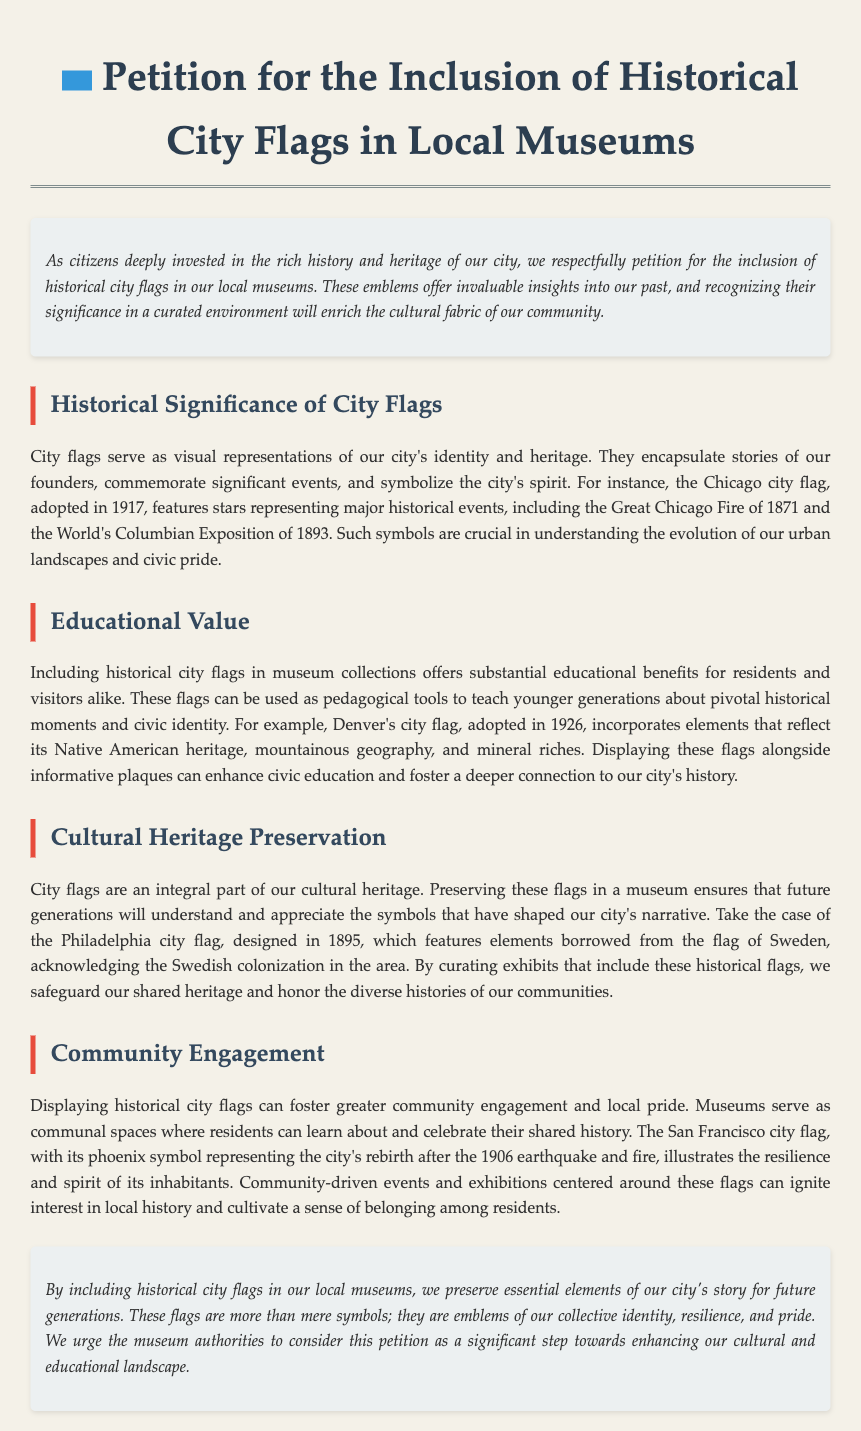what is the title of the petition? The title is clearly stated at the top of the document in a prominent header format.
Answer: Petition for the Inclusion of Historical City Flags in Local Museums when was the Chicago city flag adopted? The document specifies the adoption year of the Chicago city flag as part of its historical significance section.
Answer: 1917 what does the Denver city flag represent? The document describes elements of the Denver city flag that reflect certain aspects of the city's identity.
Answer: Native American heritage which city flag features a phoenix? The document mentions a specific city flag and its symbolism related to a significant historical event.
Answer: San Francisco city flag what is the purpose of including historical flags in local museums? The document outlines various benefits of displaying historical city flags in museums, emphasizing education and heritage.
Answer: Educational benefits what year was the Philadelphia city flag designed? The document provides the year of design for the Philadelphia city flag as part of its heritage description.
Answer: 1895 how can community engagement be fostered according to the petition? The petition discusses the role of museums in promoting local pride and history through the display of city flags.
Answer: Community-driven events what significant event is represented by the stars on the Chicago flag? The document notes specific historical events symbolized by elements on the Chicago city flag.
Answer: Great Chicago Fire why are city flags important to cultural heritage? The petition emphasizes the significance of city flags in understanding the historical narrative of the city.
Answer: Integral part of our cultural heritage 